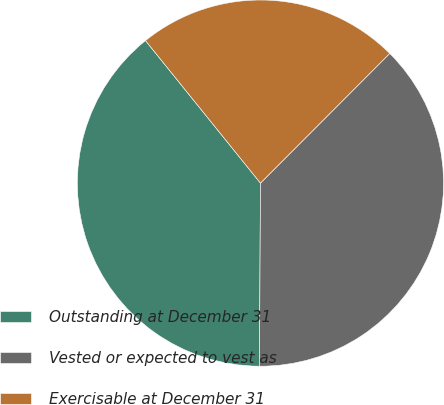Convert chart to OTSL. <chart><loc_0><loc_0><loc_500><loc_500><pie_chart><fcel>Outstanding at December 31<fcel>Vested or expected to vest as<fcel>Exercisable at December 31<nl><fcel>39.11%<fcel>37.61%<fcel>23.28%<nl></chart> 